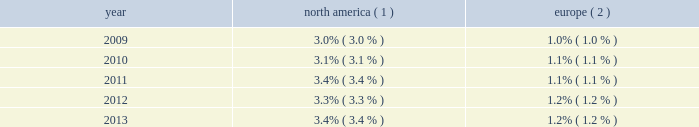Pullmantur during 2013 , we operated four ships with an aggre- gate capacity of approximately 7650 berths under our pullmantur brand , offering cruise itineraries that ranged from four to 12 nights throughout south america , the caribbean and europe .
One of these ships , zenith , was redeployed from pullmantur to cdf croisi e8res de france in january 2014 .
Pullmantur serves the contemporary segment of the spanish , portuguese and latin american cruise markets .
Pullmantur 2019s strategy is to attract cruise guests from these target markets by providing a variety of cruising options and onboard activities directed at couples and families traveling with children .
Over the last few years , pullmantur has systematically increased its focus on latin america .
In recognition of this , pullmantur recently opened a regional head office in panama to place the operating management closer to its largest and fastest growing market .
In order to facilitate pullmantur 2019s ability to focus on its core cruise business , in december 2013 , pullmantur reached an agreement to sell the majority of its inter- est in its land-based tour operations , travel agency and pullmantur air , the closing of which is subject to customary closing conditions .
In connection with the agreement , we will retain a 19% ( 19 % ) interest in the non-core businesses .
We will retain ownership of the pullmantur aircraft which will be dry leased to pullmantur air .
Cdf croisi e8res de france in january 2014 , we redeployed zenith from pullmantur to cdf croisi e8res de france .
As a result , as of january 2014 , we operate two ships with an aggregate capac- ity of approximately 2750 berths under our cdf croisi e8res de france brand .
During the summer of 2014 , cdf croisi e8res de france will operate both ships in europe and , for the first time , the brand will operate in the caribbean during the winter of 2014 .
In addition , cdf croisi e8res de france offers seasonal itineraries to the mediterranean .
Cdf croisi e8res de france is designed to serve the contemporary seg- ment of the french cruise market by providing a brand tailored for french cruise guests .
Tui cruises tui cruises is designed to serve the contemporary and premium segments of the german cruise market by offering a product tailored for german guests .
All onboard activities , services , shore excursions and menu offerings are designed to suit the preferences of this target market .
Tui cruises operates two ships , mein schiff 1 and mein schiff 2 , with an aggregate capacity of approximately 3800 berths .
In addition , tui cruises has two ships on order , each with a capacity of 2500 berths , scheduled for delivery in the second quarter of 2014 and second quarter of 2015 .
Tui cruises is a joint venture owned 50% ( 50 % ) by us and 50% ( 50 % ) by tui ag , a german tourism and shipping company that also owns 51% ( 51 % ) of tui travel , a british tourism company .
Industry cruising is considered a well-established vacation sector in the north american market , a growing sec- tor over the long-term in the european market and a developing but promising sector in several other emerging markets .
Industry data indicates that market penetration rates are still low and that a significant portion of cruise guests carried are first-time cruisers .
We believe this presents an opportunity for long-term growth and a potential for increased profitability .
The table details market penetration rates for north america and europe computed based on the number of annual cruise guests as a percentage of the total population : america ( 1 ) europe ( 2 ) .
( 1 ) source : international monetary fund and cruise line international association based on cruise guests carried for at least two con- secutive nights for years 2009 through 2012 .
Year 2013 amounts represent our estimates .
Includes the united states of america and canada .
( 2 ) source : international monetary fund and clia europe , formerly european cruise council , for years 2009 through 2012 .
Year 2013 amounts represent our estimates .
We estimate that the global cruise fleet was served by approximately 436000 berths on approximately 269 ships at the end of 2013 .
There are approximately 26 ships with an estimated 71000 berths that are expected to be placed in service in the global cruise market between 2014 and 2018 , although it is also possible that ships could be ordered or taken out of service during these periods .
We estimate that the global cruise industry carried 21.3 million cruise guests in 2013 compared to 20.9 million cruise guests carried in 2012 and 20.2 million cruise guests carried in 2011 .
Part i .
By what percentage did the global cruise guests increase from 2011 to 2012 and from 2012 to 2013? 
Computations: ((21.3 - 20.9) / 20.9)
Answer: 0.01914. 